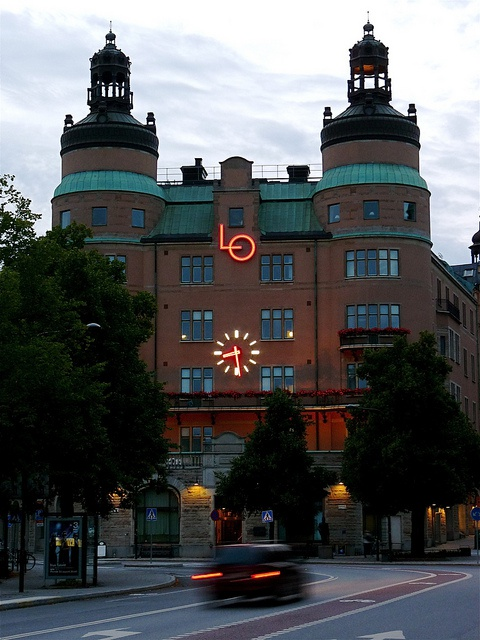Describe the objects in this image and their specific colors. I can see car in white, black, gray, and darkblue tones, clock in white and maroon tones, and bicycle in white, black, blue, and darkblue tones in this image. 